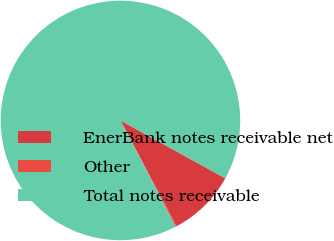Convert chart. <chart><loc_0><loc_0><loc_500><loc_500><pie_chart><fcel>EnerBank notes receivable net<fcel>Other<fcel>Total notes receivable<nl><fcel>9.21%<fcel>0.16%<fcel>90.63%<nl></chart> 